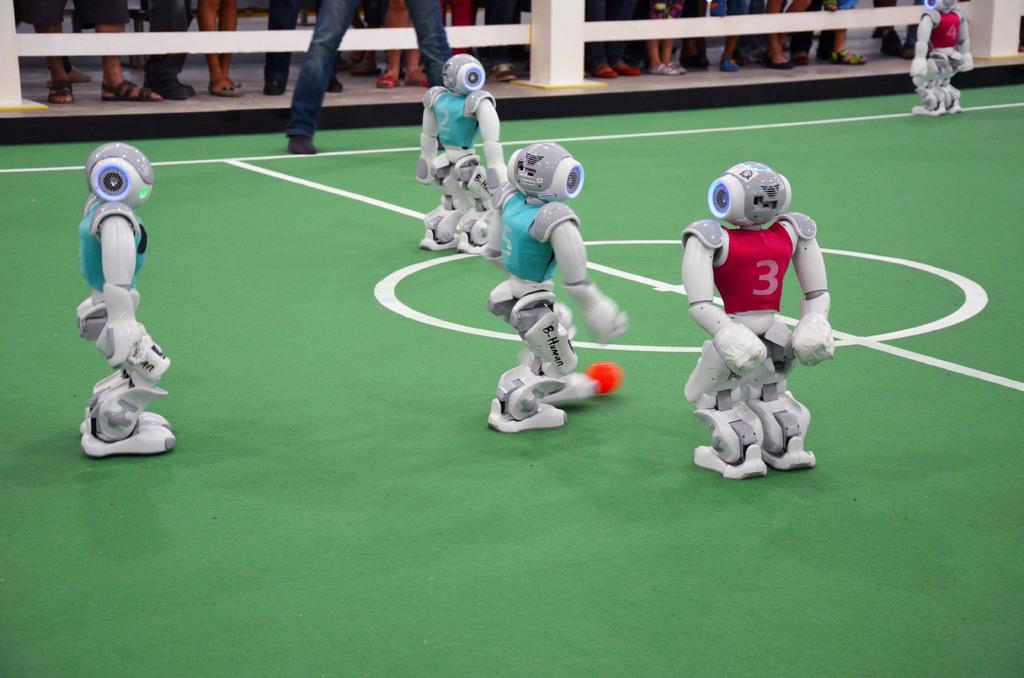What number is on the red jersey?
Give a very brief answer. 3. 